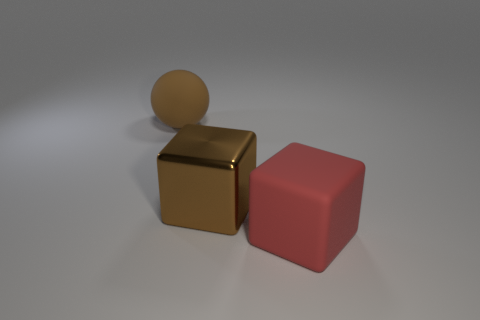Are there any other things that have the same size as the red rubber block?
Provide a short and direct response. Yes. There is a large red block; what number of balls are to the right of it?
Give a very brief answer. 0. Are there the same number of big red blocks behind the big brown metal cube and small cyan cylinders?
Offer a very short reply. Yes. What number of objects are either large gray shiny cylinders or big matte blocks?
Your response must be concise. 1. Is there anything else that has the same shape as the brown shiny object?
Your answer should be very brief. Yes. There is a matte object left of the big rubber thing in front of the matte ball; what is its shape?
Provide a succinct answer. Sphere. The thing that is the same material as the large ball is what shape?
Your response must be concise. Cube. There is a brown object behind the brown thing that is in front of the brown ball; what size is it?
Ensure brevity in your answer.  Large. There is a large red rubber object; what shape is it?
Keep it short and to the point. Cube. What number of small things are either rubber objects or brown spheres?
Make the answer very short. 0. 